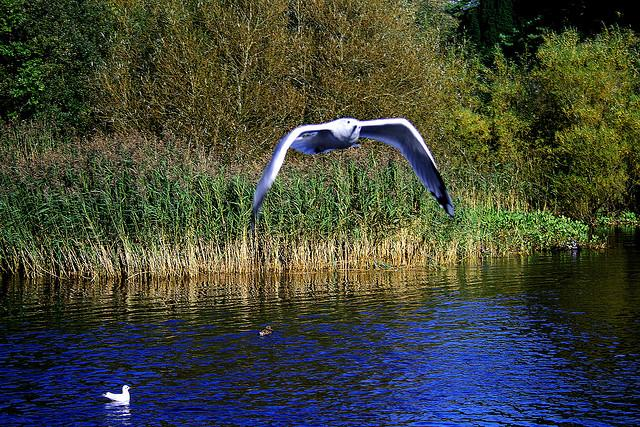The bird on the water has what type feet? webbed 